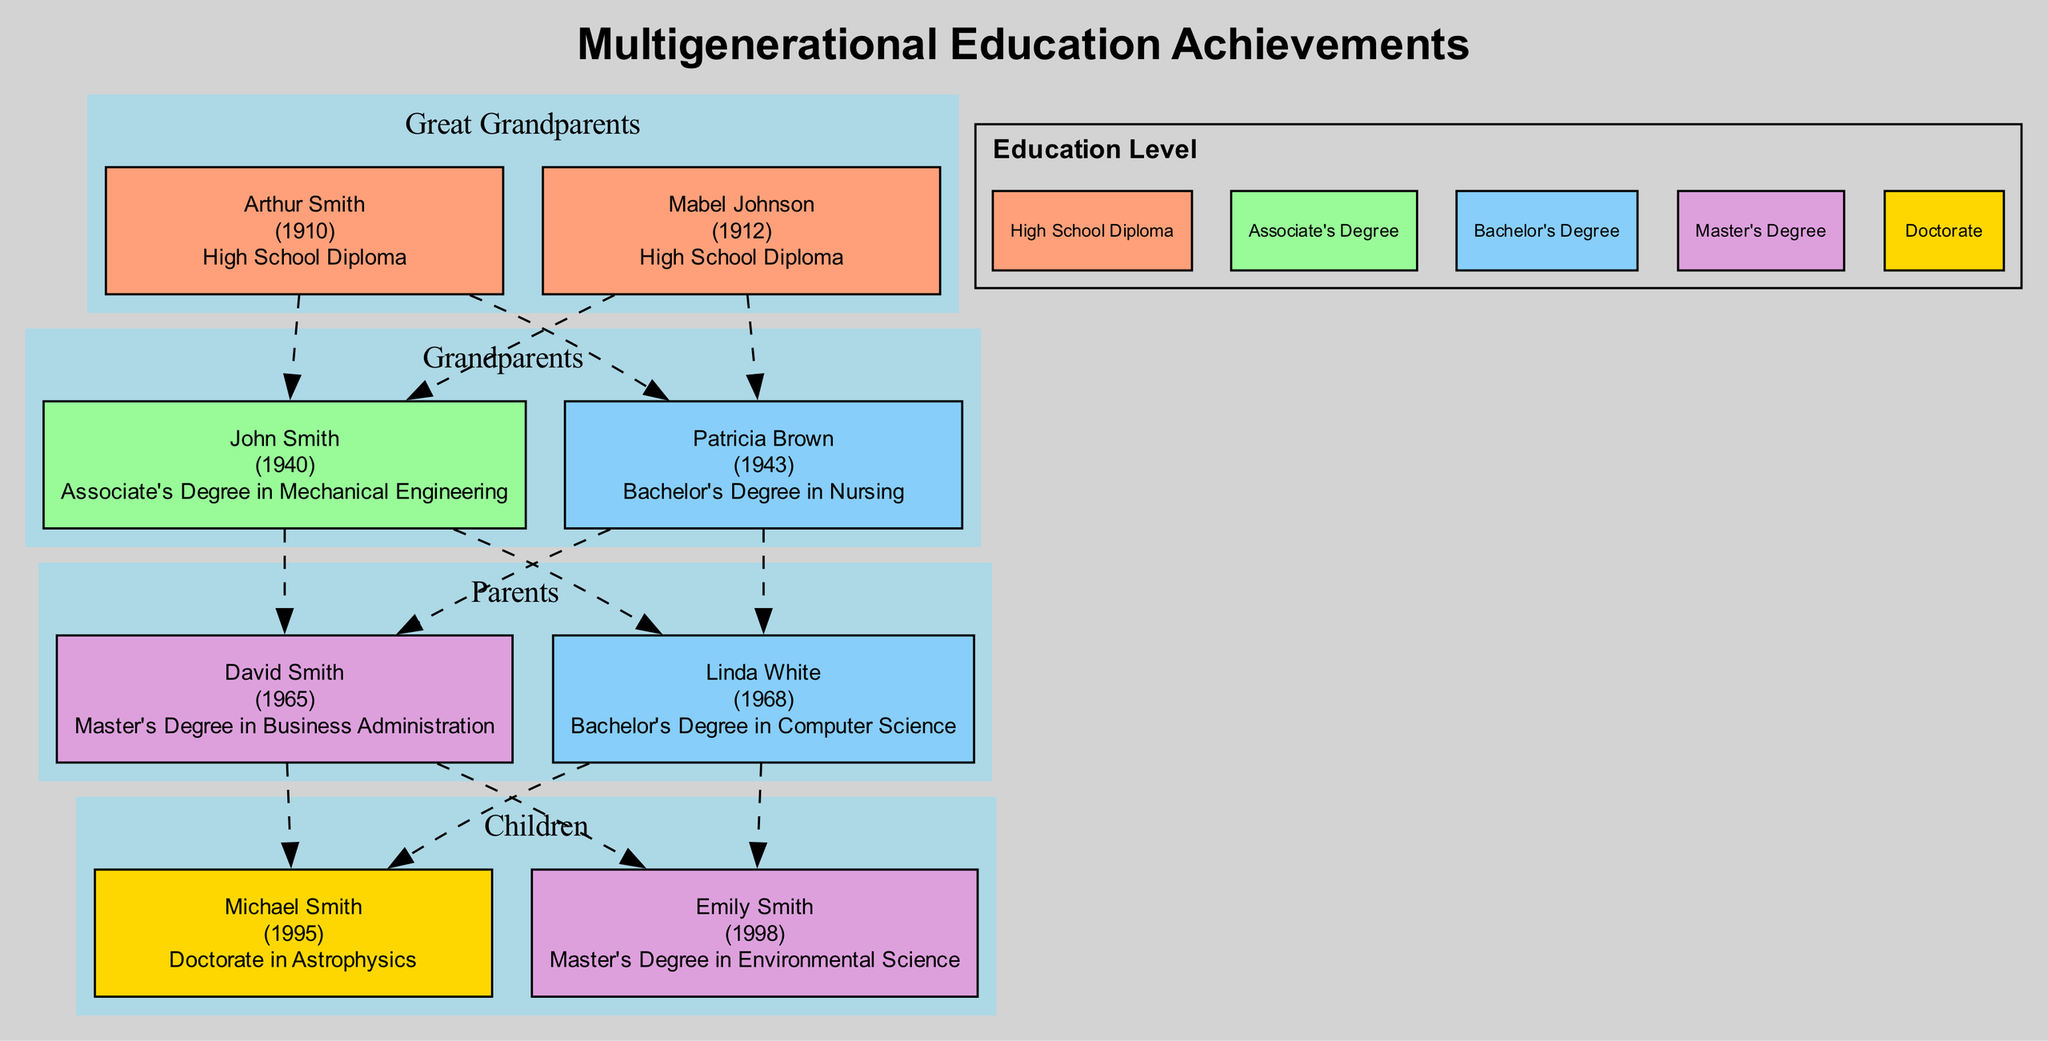What is the highest education level achieved by Arthur Smith? In the diagram, Arthur Smith is listed under the "Great Grandparents" generation. The diagram specifies his highest education level as "High School Diploma."
Answer: High School Diploma What generation does Emily Smith belong to? Emily Smith is shown under the "Children" generation in the diagram, which categorizes her as part of this particular generational group.
Answer: Children How many members achieved a Bachelor's Degree? To determine this, I count the number of nodes labeled with "Bachelor's Degree" in the diagram. Patricia Brown and Linda White each achieved this education level, making a total of two members.
Answer: 2 Which family member has the highest education level? Analyzing the education levels presented in the diagram, Michael Smith is indicated as having a "Doctorate in Astrophysics," which is the highest level of education among all family members displayed.
Answer: Doctorate in Astrophysics Which generation has members with the highest educational attainment? By comparing the highest education levels across all generations, it's clear that the "Children" generation, represented by Michael Smith and Emily Smith, has members achieving the highest educational levels, including a Doctorate and a Master's Degree.
Answer: Children How many people are in the Grandparents generation? The diagram displays two members in the "Grandparents" generation, namely John Smith and Patricia Brown, leading to the conclusion that there are two individuals in this generational category.
Answer: 2 Who is directly connected to David Smith in the diagram? David Smith is located in the "Parents" generation. Tracing the connections, the diagram shows that he is connected to his children, Michael Smith and Emily Smith. Thus, both names are directly related to David Smith.
Answer: Michael Smith, Emily Smith What trend is observed in educational attainment over generations? The diagram's trend summary indicates that there is a significant increase in educational attainment over generations, implying that more recent generations are achieving higher levels of education compared to their predecessors.
Answer: Increase in educational attainment What is the birth year of Patricia Brown? Within the diagram, Patricia Brown's name is highlighted, and her corresponding birth year is stated as 1943. This information identifies her specific age relative to the other family members.
Answer: 1943 